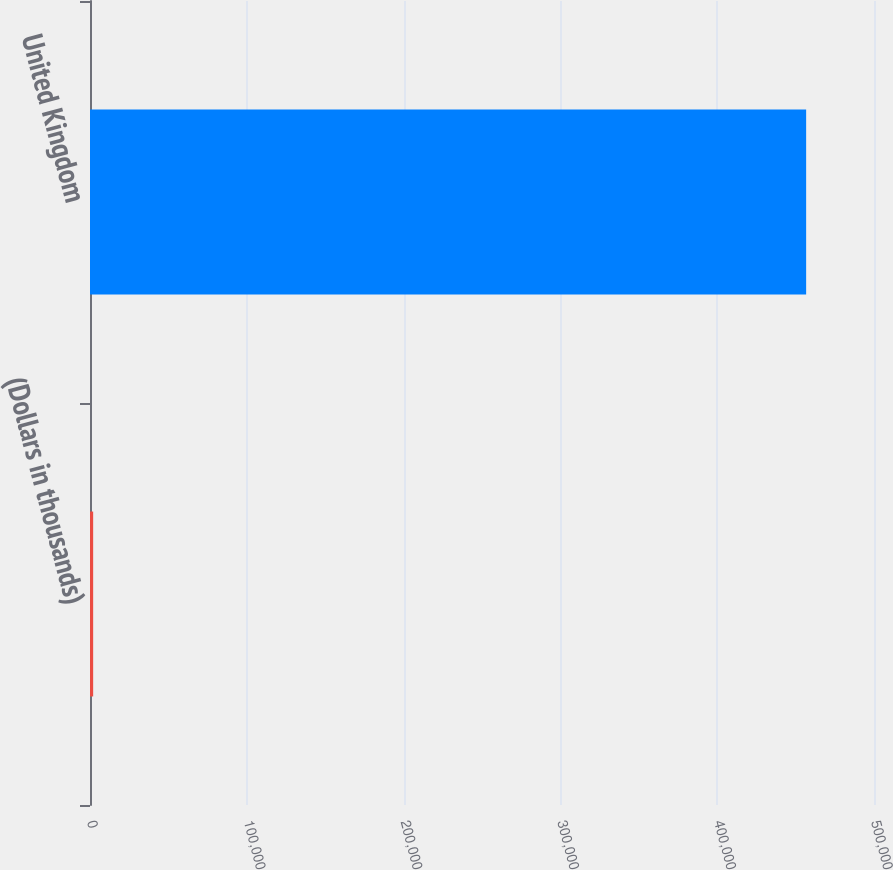Convert chart. <chart><loc_0><loc_0><loc_500><loc_500><bar_chart><fcel>(Dollars in thousands)<fcel>United Kingdom<nl><fcel>2012<fcel>456724<nl></chart> 